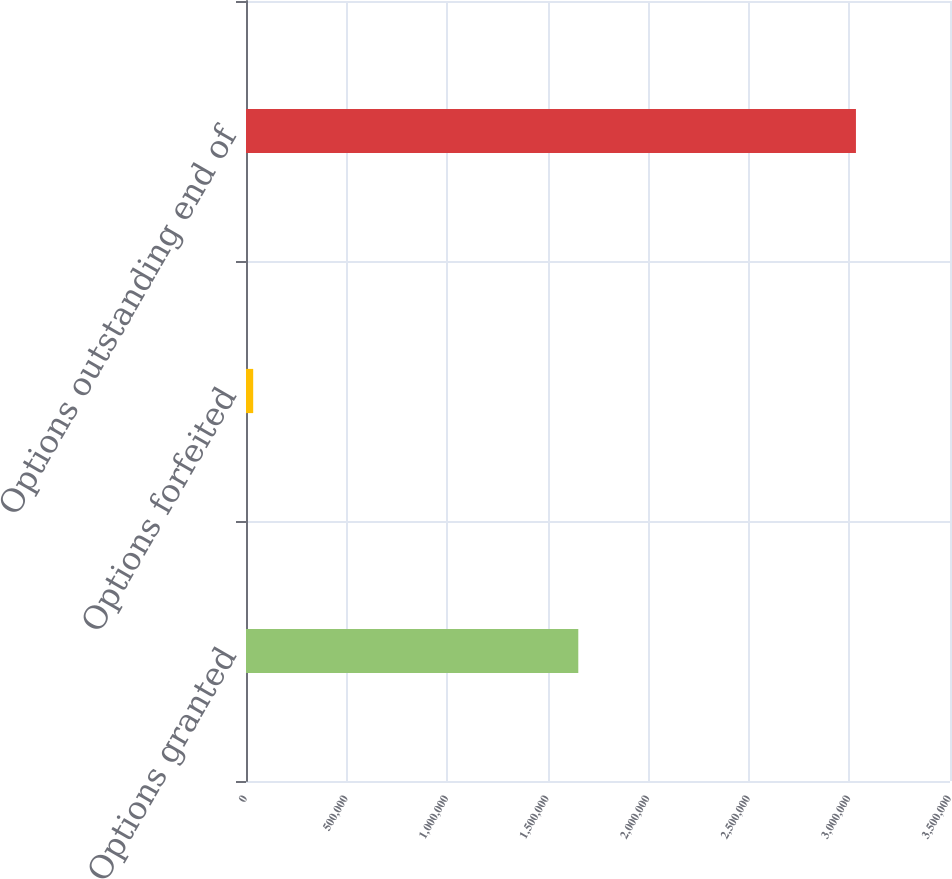Convert chart to OTSL. <chart><loc_0><loc_0><loc_500><loc_500><bar_chart><fcel>Options granted<fcel>Options forfeited<fcel>Options outstanding end of<nl><fcel>1.65205e+06<fcel>35776<fcel>3.0324e+06<nl></chart> 